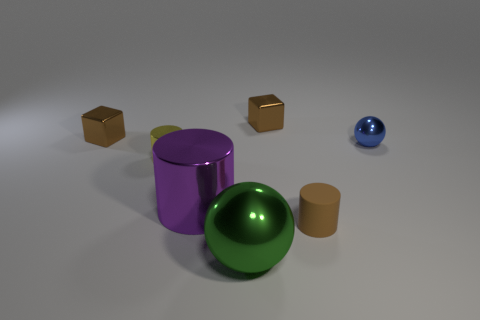Is the color of the tiny shiny thing that is to the left of the yellow shiny cylinder the same as the matte cylinder?
Offer a terse response. Yes. There is a small brown object that is on the left side of the yellow metallic cylinder; does it have the same shape as the tiny brown shiny object that is on the right side of the big purple cylinder?
Provide a short and direct response. Yes. There is a small yellow thing that is the same shape as the purple shiny object; what material is it?
Your response must be concise. Metal. Are the green sphere and the small cylinder right of the green metallic ball made of the same material?
Make the answer very short. No. Is there any other thing of the same color as the small matte thing?
Your response must be concise. Yes. What number of objects are either metallic balls that are behind the small matte thing or metal spheres that are behind the green ball?
Offer a very short reply. 1. What is the shape of the object that is behind the small blue metal ball and on the left side of the purple metal cylinder?
Give a very brief answer. Cube. There is a tiny cylinder right of the big purple metal object; how many blue metal spheres are left of it?
Provide a succinct answer. 0. Is there any other thing that is made of the same material as the large cylinder?
Ensure brevity in your answer.  Yes. How many things are either spheres behind the green metallic ball or small blue things?
Provide a succinct answer. 1. 